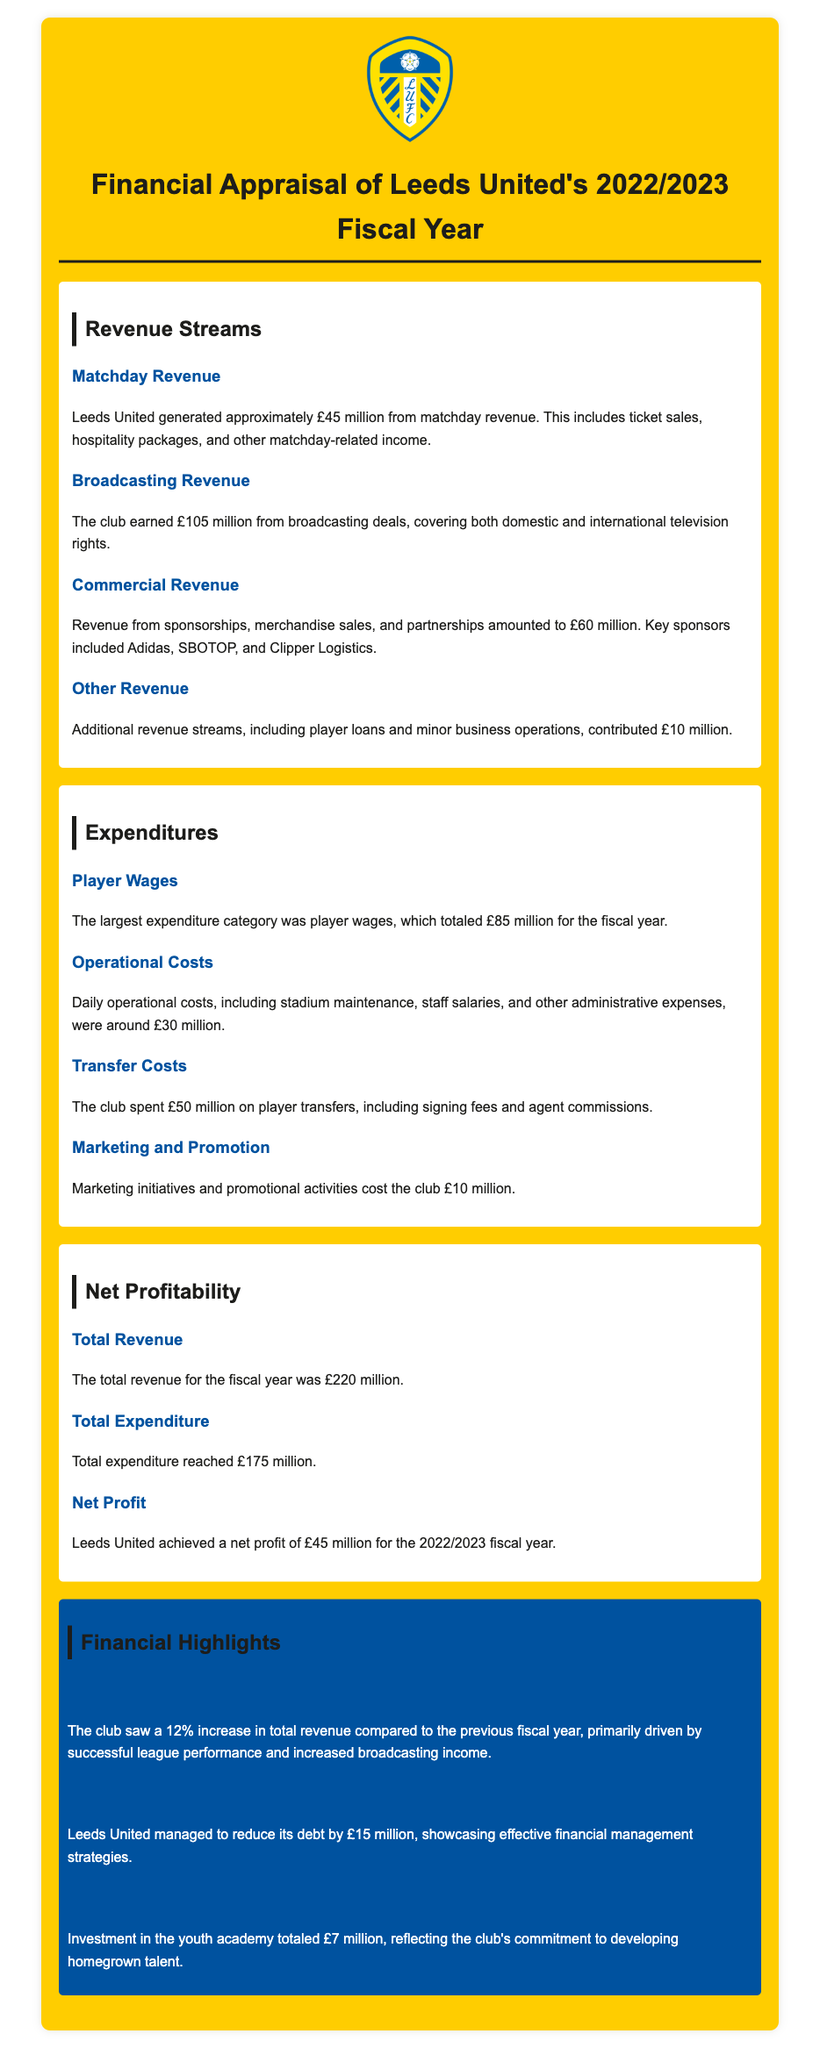What is the total revenue? The total revenue is summarized in the document as £220 million from various sources.
Answer: £220 million How much was generated from broadcasting revenue? The document specifies the amount earned from broadcasting deals as £105 million.
Answer: £105 million What was the expenditure on player wages? The document indicates that the largest expenditure was player wages, totaling £85 million.
Answer: £85 million What is the net profit for the fiscal year? The document states that Leeds United achieved a net profit of £45 million for the 2022/2023 fiscal year.
Answer: £45 million By how much did total revenue increase compared to the previous fiscal year? The document mentions a 12% increase in total revenue compared to the previous fiscal year.
Answer: 12% What were the total operational costs? The daily operational costs, including various expenses, were specified as around £30 million.
Answer: £30 million How much was invested in the youth academy? The investment in the youth academy is disclosed as £7 million in the financial highlights section.
Answer: £7 million What key sponsors contributed to commercial revenue? The document lists Adidas, SBOTOP, and Clipper Logistics as key sponsors.
Answer: Adidas, SBOTOP, Clipper Logistics What was the total expenditure for the year? The total expenditure for the fiscal year is clearly stated as £175 million.
Answer: £175 million How much did the club reduce its debt? The document reports a reduction in debt by £15 million as part of financial management strategies.
Answer: £15 million 